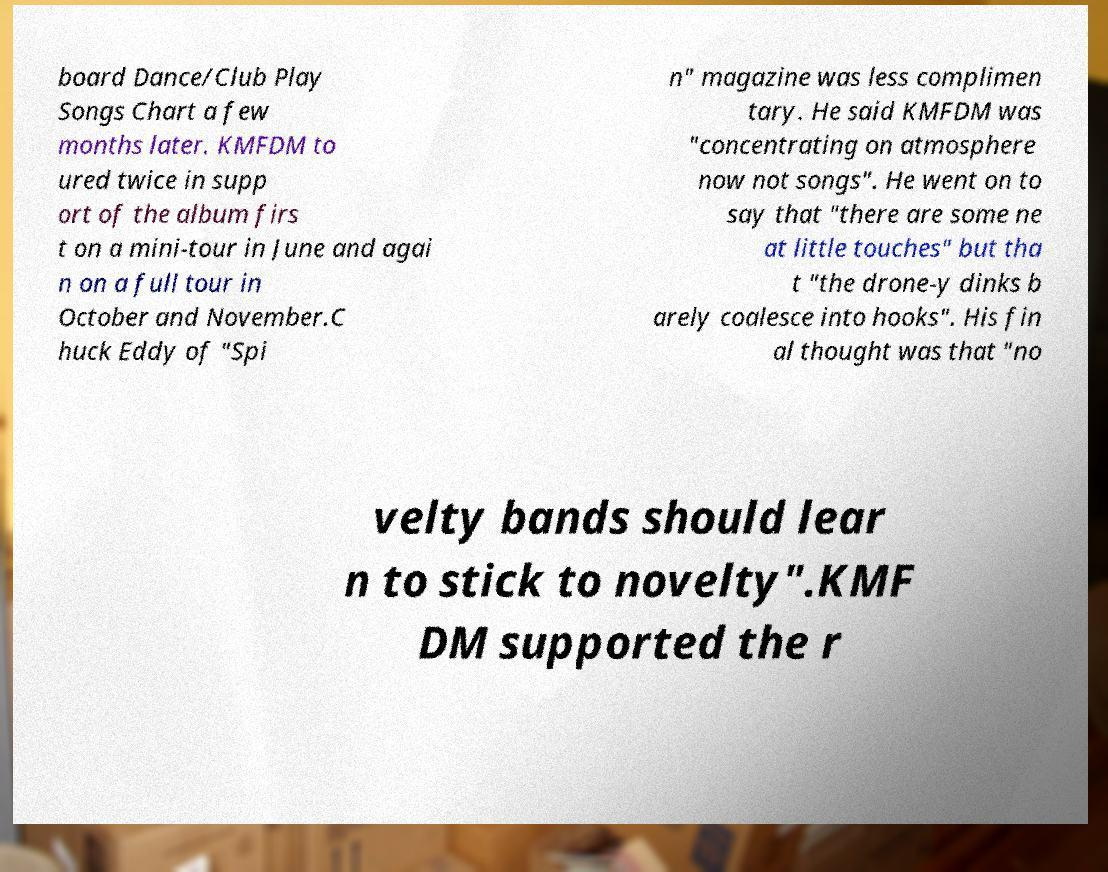Please read and relay the text visible in this image. What does it say? board Dance/Club Play Songs Chart a few months later. KMFDM to ured twice in supp ort of the album firs t on a mini-tour in June and agai n on a full tour in October and November.C huck Eddy of "Spi n" magazine was less complimen tary. He said KMFDM was "concentrating on atmosphere now not songs". He went on to say that "there are some ne at little touches" but tha t "the drone-y dinks b arely coalesce into hooks". His fin al thought was that "no velty bands should lear n to stick to novelty".KMF DM supported the r 